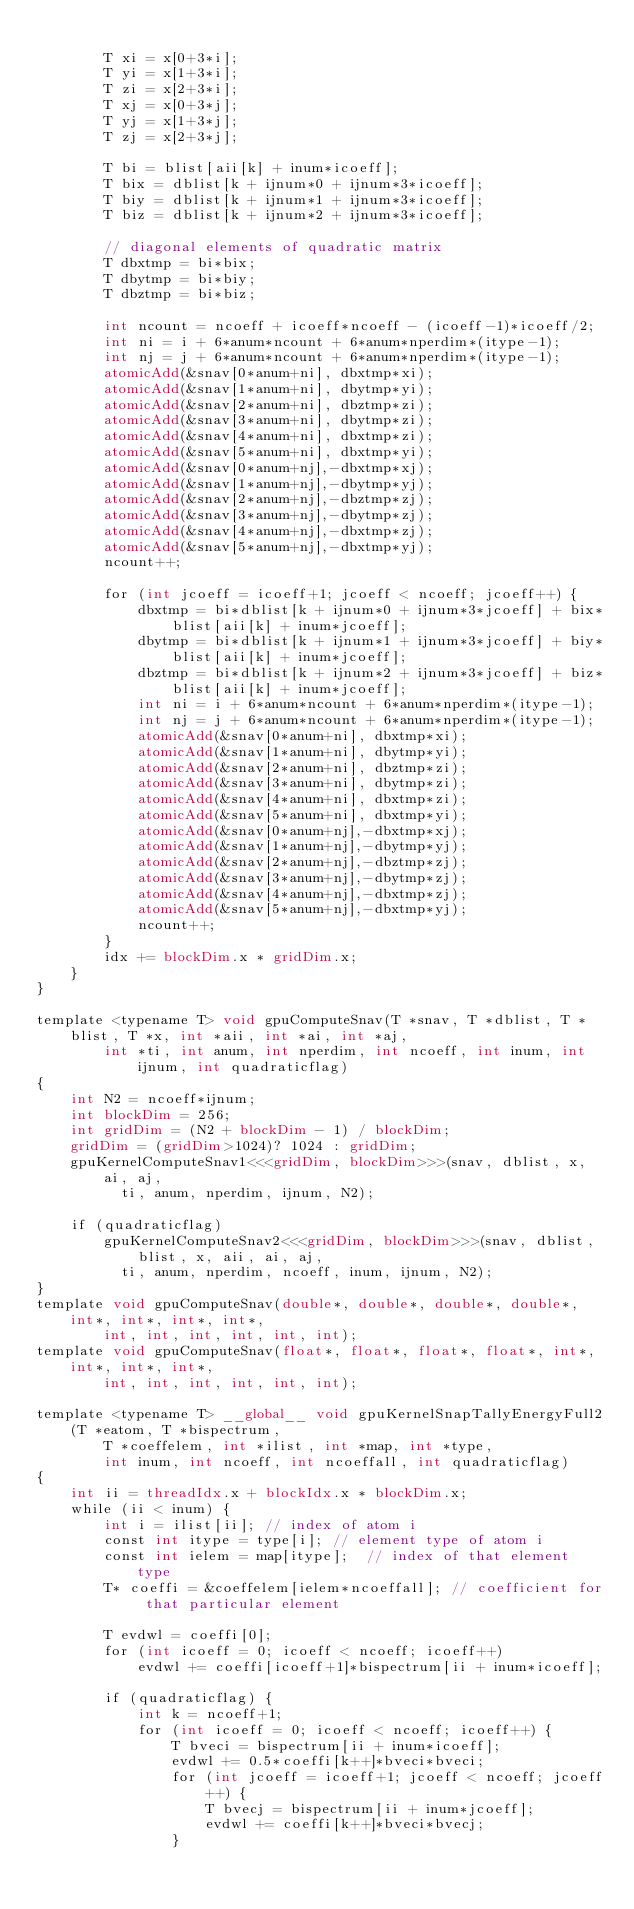Convert code to text. <code><loc_0><loc_0><loc_500><loc_500><_Cuda_>
        T xi = x[0+3*i]; 
        T yi = x[1+3*i]; 
        T zi = x[2+3*i]; 
        T xj = x[0+3*j]; 
        T yj = x[1+3*j]; 
        T zj = x[2+3*j];             

        T bi = blist[aii[k] + inum*icoeff];
        T bix = dblist[k + ijnum*0 + ijnum*3*icoeff];
        T biy = dblist[k + ijnum*1 + ijnum*3*icoeff];
        T biz = dblist[k + ijnum*2 + ijnum*3*icoeff];

        // diagonal elements of quadratic matrix
        T dbxtmp = bi*bix;
        T dbytmp = bi*biy;
        T dbztmp = bi*biz;

        int ncount = ncoeff + icoeff*ncoeff - (icoeff-1)*icoeff/2;            
        int ni = i + 6*anum*ncount + 6*anum*nperdim*(itype-1);
        int nj = j + 6*anum*ncount + 6*anum*nperdim*(itype-1);
        atomicAdd(&snav[0*anum+ni], dbxtmp*xi);
        atomicAdd(&snav[1*anum+ni], dbytmp*yi);
        atomicAdd(&snav[2*anum+ni], dbztmp*zi);
        atomicAdd(&snav[3*anum+ni], dbytmp*zi);
        atomicAdd(&snav[4*anum+ni], dbxtmp*zi);
        atomicAdd(&snav[5*anum+ni], dbxtmp*yi);
        atomicAdd(&snav[0*anum+nj],-dbxtmp*xj);
        atomicAdd(&snav[1*anum+nj],-dbytmp*yj);
        atomicAdd(&snav[2*anum+nj],-dbztmp*zj);
        atomicAdd(&snav[3*anum+nj],-dbytmp*zj);
        atomicAdd(&snav[4*anum+nj],-dbxtmp*zj);
        atomicAdd(&snav[5*anum+nj],-dbxtmp*yj);
        ncount++;      

        for (int jcoeff = icoeff+1; jcoeff < ncoeff; jcoeff++) {
            dbxtmp = bi*dblist[k + ijnum*0 + ijnum*3*jcoeff] + bix*blist[aii[k] + inum*jcoeff]; 
            dbytmp = bi*dblist[k + ijnum*1 + ijnum*3*jcoeff] + biy*blist[aii[k] + inum*jcoeff];
            dbztmp = bi*dblist[k + ijnum*2 + ijnum*3*jcoeff] + biz*blist[aii[k] + inum*jcoeff];
            int ni = i + 6*anum*ncount + 6*anum*nperdim*(itype-1);
            int nj = j + 6*anum*ncount + 6*anum*nperdim*(itype-1);
            atomicAdd(&snav[0*anum+ni], dbxtmp*xi);
            atomicAdd(&snav[1*anum+ni], dbytmp*yi);
            atomicAdd(&snav[2*anum+ni], dbztmp*zi);
            atomicAdd(&snav[3*anum+ni], dbytmp*zi);
            atomicAdd(&snav[4*anum+ni], dbxtmp*zi);
            atomicAdd(&snav[5*anum+ni], dbxtmp*yi);
            atomicAdd(&snav[0*anum+nj],-dbxtmp*xj);
            atomicAdd(&snav[1*anum+nj],-dbytmp*yj);
            atomicAdd(&snav[2*anum+nj],-dbztmp*zj);
            atomicAdd(&snav[3*anum+nj],-dbytmp*zj);
            atomicAdd(&snav[4*anum+nj],-dbxtmp*zj);
            atomicAdd(&snav[5*anum+nj],-dbxtmp*yj);
            ncount++;      
        }                                    
        idx += blockDim.x * gridDim.x;
    }
}

template <typename T> void gpuComputeSnav(T *snav, T *dblist, T *blist, T *x, int *aii, int *ai, int *aj,
        int *ti, int anum, int nperdim, int ncoeff, int inum, int ijnum, int quadraticflag)
{        
    int N2 = ncoeff*ijnum;
    int blockDim = 256;
    int gridDim = (N2 + blockDim - 1) / blockDim;
    gridDim = (gridDim>1024)? 1024 : gridDim;        
    gpuKernelComputeSnav1<<<gridDim, blockDim>>>(snav, dblist, x, ai, aj, 
          ti, anum, nperdim, ijnum, N2);

    if (quadraticflag)
        gpuKernelComputeSnav2<<<gridDim, blockDim>>>(snav, dblist, blist, x, aii, ai, aj, 
          ti, anum, nperdim, ncoeff, inum, ijnum, N2);
}
template void gpuComputeSnav(double*, double*, double*, double*, int*, int*, int*, int*, 
        int, int, int, int, int, int);
template void gpuComputeSnav(float*, float*, float*, float*, int*, int*, int*, int*, 
        int, int, int, int, int, int);

template <typename T> __global__ void gpuKernelSnapTallyEnergyFull2(T *eatom, T *bispectrum, 
        T *coeffelem, int *ilist, int *map, int *type, 
        int inum, int ncoeff, int ncoeffall, int quadraticflag)
{      
    int ii = threadIdx.x + blockIdx.x * blockDim.x;
    while (ii < inum) {        
        int i = ilist[ii]; // index of atom i
        const int itype = type[i]; // element type of atom i
        const int ielem = map[itype];  // index of that element type
        T* coeffi = &coeffelem[ielem*ncoeffall]; // coefficient for that particular element
        
        T evdwl = coeffi[0];
        for (int icoeff = 0; icoeff < ncoeff; icoeff++)
            evdwl += coeffi[icoeff+1]*bispectrum[ii + inum*icoeff];
                  
        if (quadraticflag) {
            int k = ncoeff+1;
            for (int icoeff = 0; icoeff < ncoeff; icoeff++) {
                T bveci = bispectrum[ii + inum*icoeff];
                evdwl += 0.5*coeffi[k++]*bveci*bveci;
                for (int jcoeff = icoeff+1; jcoeff < ncoeff; jcoeff++) {
                    T bvecj = bispectrum[ii + inum*jcoeff];
                    evdwl += coeffi[k++]*bveci*bvecj;
                }</code> 